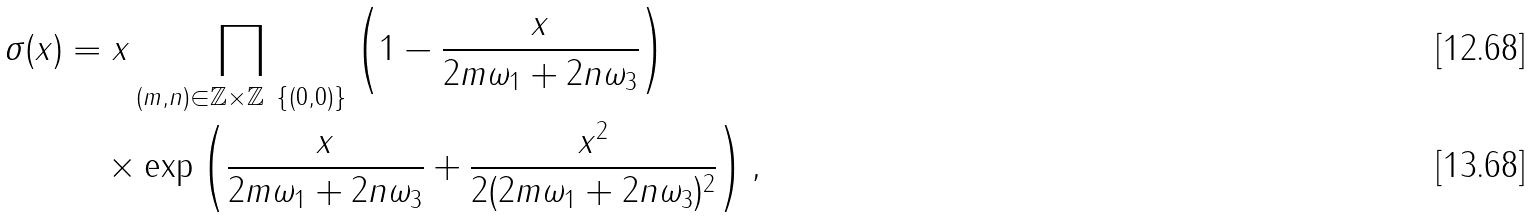Convert formula to latex. <formula><loc_0><loc_0><loc_500><loc_500>\sigma ( x ) & = x \prod _ { ( m , n ) \in \mathbb { Z } \times \mathbb { Z } \ \{ ( 0 , 0 ) \} } \left ( 1 - \frac { x } { 2 m \omega _ { 1 } + 2 n \omega _ { 3 } } \right ) \\ & \quad \times \exp \left ( \frac { x } { 2 m \omega _ { 1 } + 2 n \omega _ { 3 } } + \frac { x ^ { 2 } } { 2 ( 2 m \omega _ { 1 } + 2 n \omega _ { 3 } ) ^ { 2 } } \right ) ,</formula> 